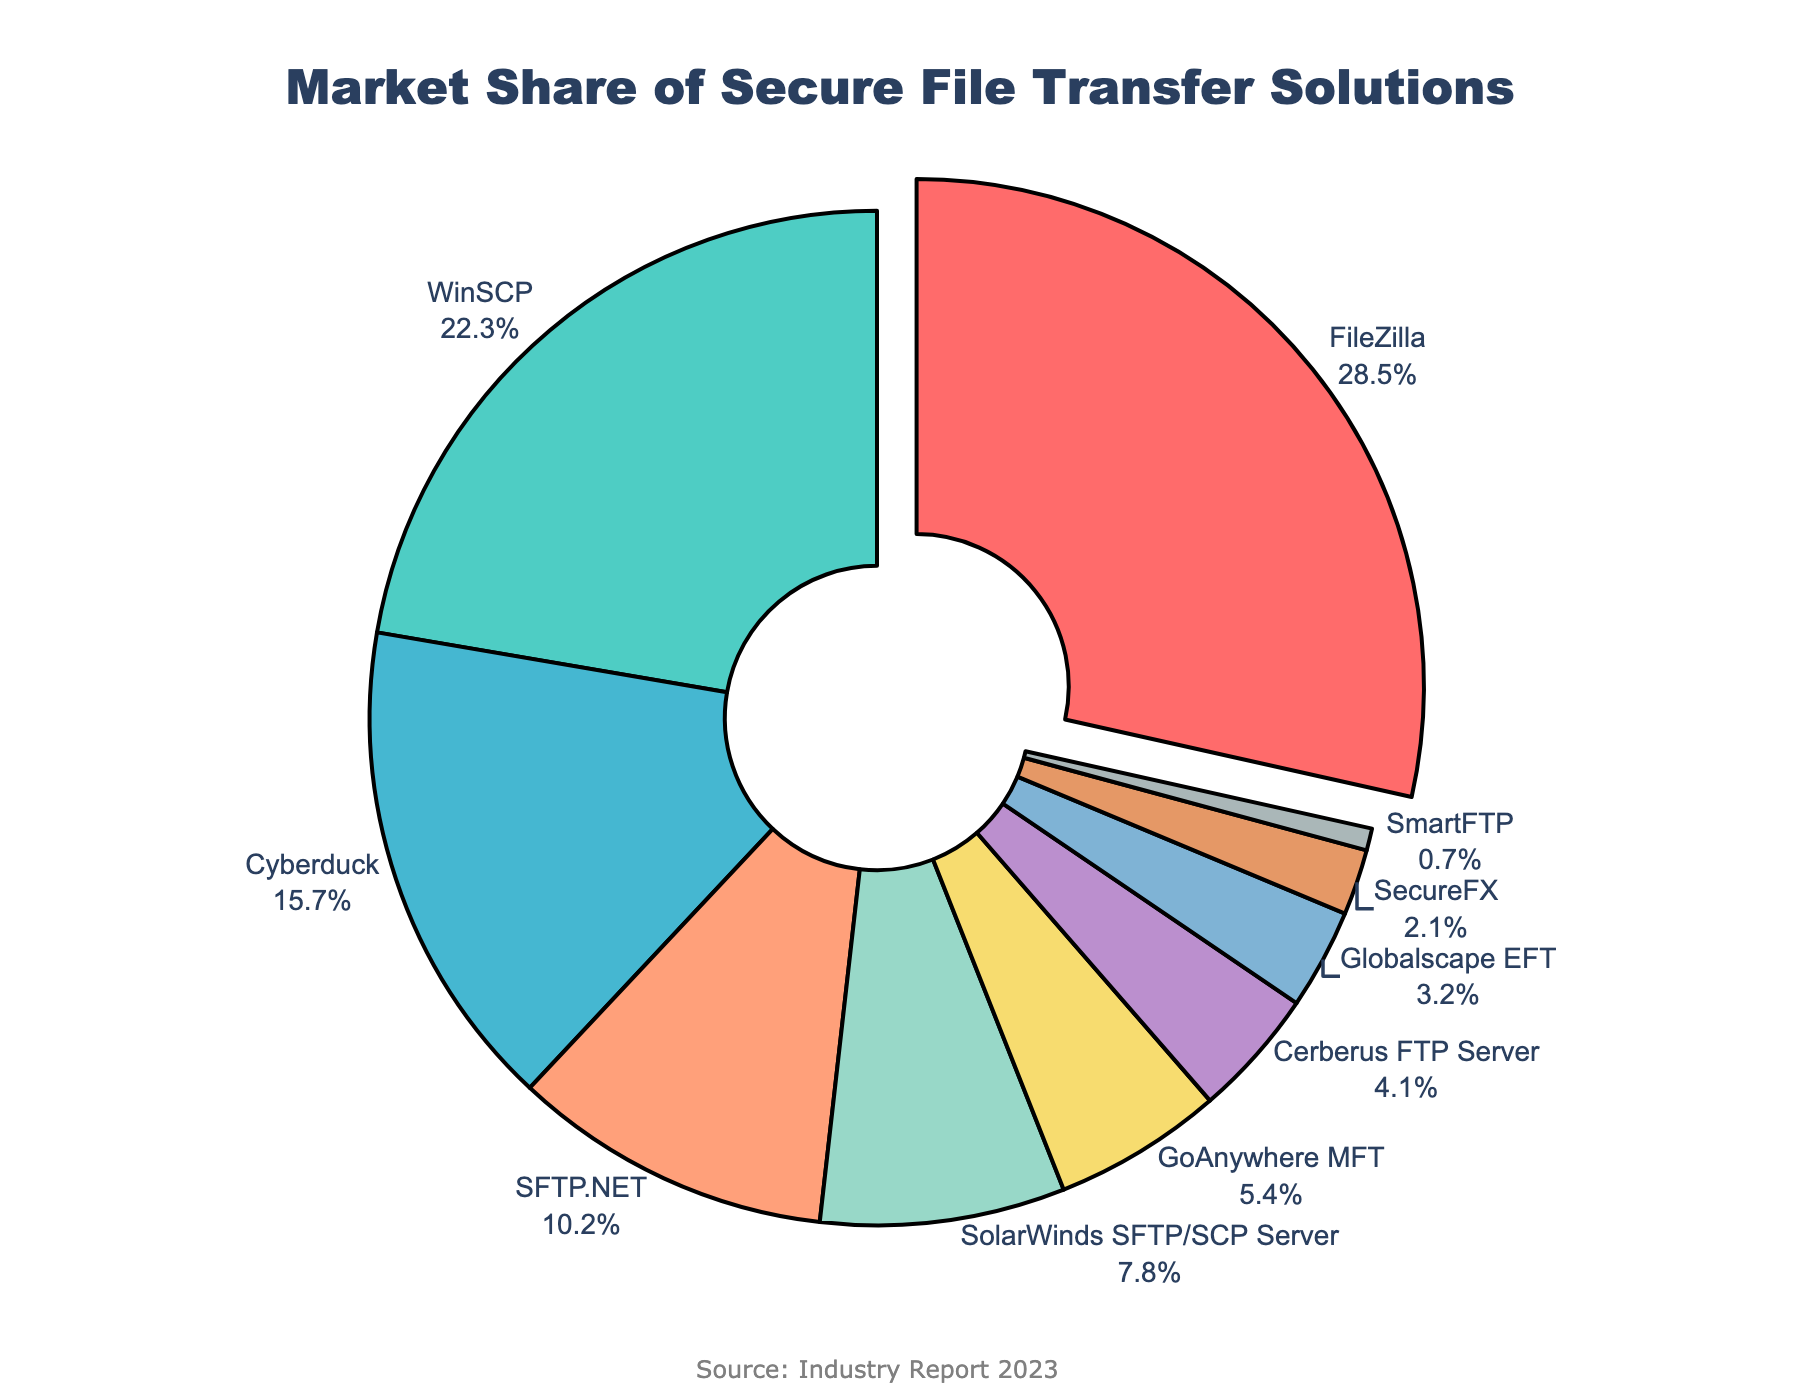What is the market share of FileZilla? FileZilla has a highlighted (pulled-out) section, and the percentage value can be seen directly on this section of the pie chart.
Answer: 28.5% Which software has the smallest market share, and what is its percentage? By observing the pie chart, SmartFTP has the smallest segment, which also indicates its percentage value of 0.7%.
Answer: SmartFTP, 0.7% How many software solutions have a market share greater than 10%? By looking at the different sections of the pie chart, FileZilla, WinSCP, Cyberduck, and SFTP.NET each have market shares greater than 10%. This counts up to four segments.
Answer: 4 software solutions Which color represents SolarWinds SFTP/SCP Server, and what is its market share? The pie chart segment for SolarWinds SFTP/SCP Server is colored yellow and shows a market share of 7.8%.
Answer: Yellow, 7.8% Are there more software solutions with market shares above or below 5%? By counting the segments visually: 
- Above 5%: FileZilla, WinSCP, Cyberduck, SFTP.NET, and SolarWinds SFTP/SCP Server (5 segments).
- Below 5%: GoAnywhere MFT, Cerberus FTP Server, Globalscape EFT, SecureFX, SmartFTP (5 segments).
There are an equal number, 5 each.
Answer: Equal number What is the combined market share of Cyberduck and GoAnywhere MFT? Adding the percentages of Cyberduck (15.7%) and GoAnywhere MFT (5.4%) yields 15.7 + 5.4 = 21.1%.
Answer: 21.1% Is the market share of WinSCP more than twice that of SecureFX? The market share of WinSCP is 22.3%, and SecureFX is 2.1%. Calculating twice SecureFX gives 2.1 * 2 = 4.2. Since 22.3 > 4.2, WinSCP's share is more than twice that of SecureFX.
Answer: Yes Which software has the third highest market share, and what is its percentage? The third largest segment in the pie chart is Cyberduck categorized visually. The corresponding percentage value is shown next to it as 15.7%.
Answer: Cyberduck, 15.7% What percentage of the market share is held by software solutions other than FileZilla and WinSCP? Subtracting the combined market share of FileZilla (28.5%) and WinSCP (22.3%) from 100%: 100 - (28.5 + 22.3) = 100 - 50.8 = 49.2%.
Answer: 49.2% What is the difference in market share between the leading (largest) and second-leading (second largest) software solutions? FileZilla has the largest market share at 28.5%, and WinSCP follows with 22.3%. The difference is calculated as 28.5 - 22.3 = 6.2%.
Answer: 6.2% 